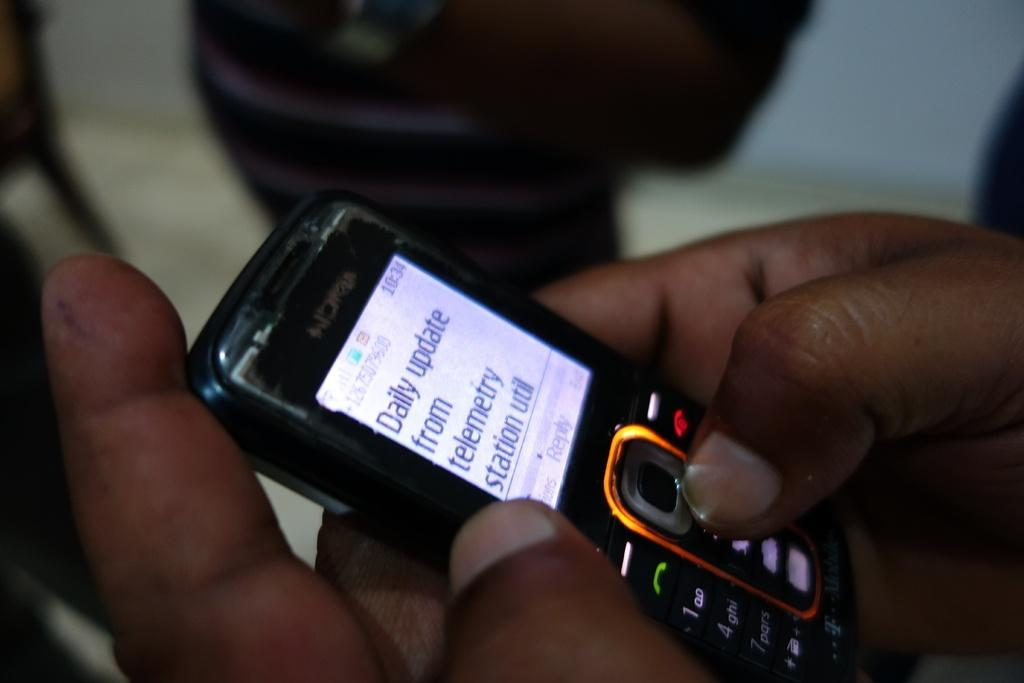<image>
Write a terse but informative summary of the picture. A person is using a phone that says Daily Update from telemetry station util. 